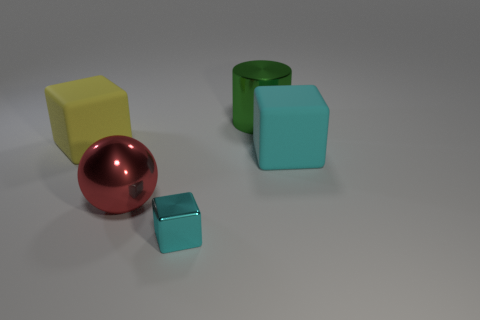Is there any other thing that is the same size as the cyan metallic block?
Ensure brevity in your answer.  No. How many matte cubes have the same color as the metal block?
Make the answer very short. 1. There is another rubber object that is the same shape as the large yellow object; what color is it?
Ensure brevity in your answer.  Cyan. What number of big red shiny spheres are right of the green shiny cylinder that is behind the yellow rubber block?
Give a very brief answer. 0. What number of cubes are either large cyan objects or red things?
Make the answer very short. 1. Are any tiny green matte cylinders visible?
Offer a terse response. No. There is another cyan rubber object that is the same shape as the small cyan thing; what is its size?
Make the answer very short. Large. There is a metal object that is behind the cyan thing to the right of the green metallic cylinder; what shape is it?
Provide a short and direct response. Cylinder. How many green objects are big spheres or metallic cylinders?
Provide a succinct answer. 1. What color is the small shiny cube?
Offer a very short reply. Cyan. 